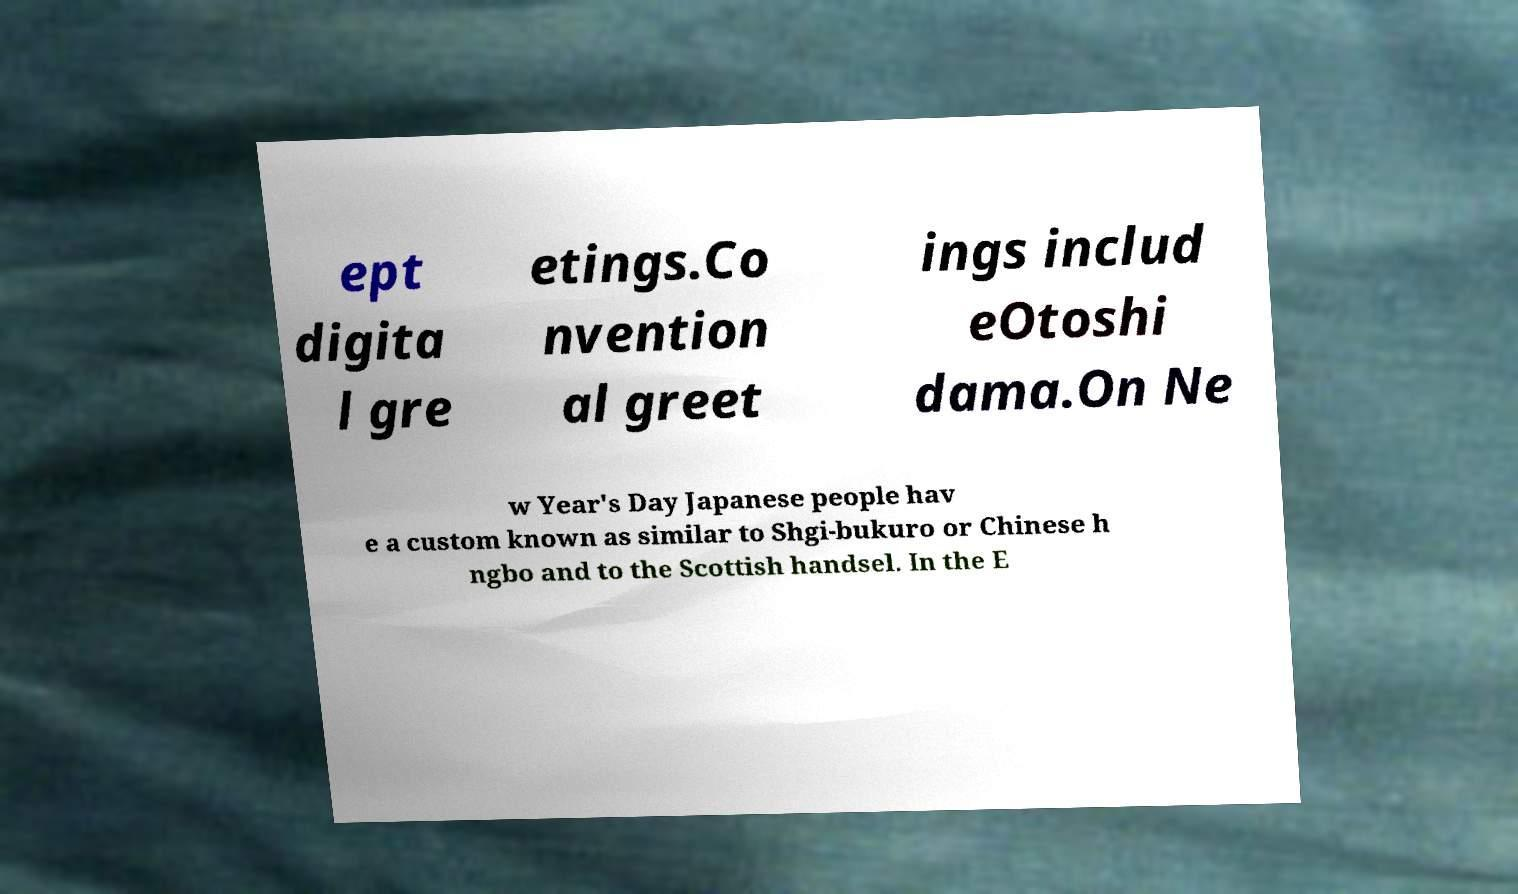Please read and relay the text visible in this image. What does it say? ept digita l gre etings.Co nvention al greet ings includ eOtoshi dama.On Ne w Year's Day Japanese people hav e a custom known as similar to Shgi-bukuro or Chinese h ngbo and to the Scottish handsel. In the E 